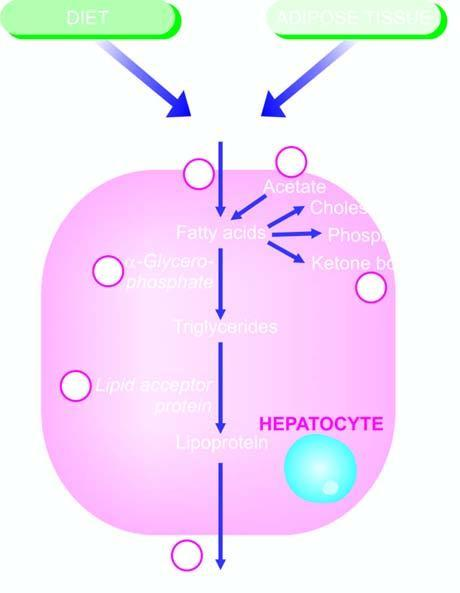what can produce fatty liver by different etiologic agents?
Answer the question using a single word or phrase. Defects in any of the six numbered steps 